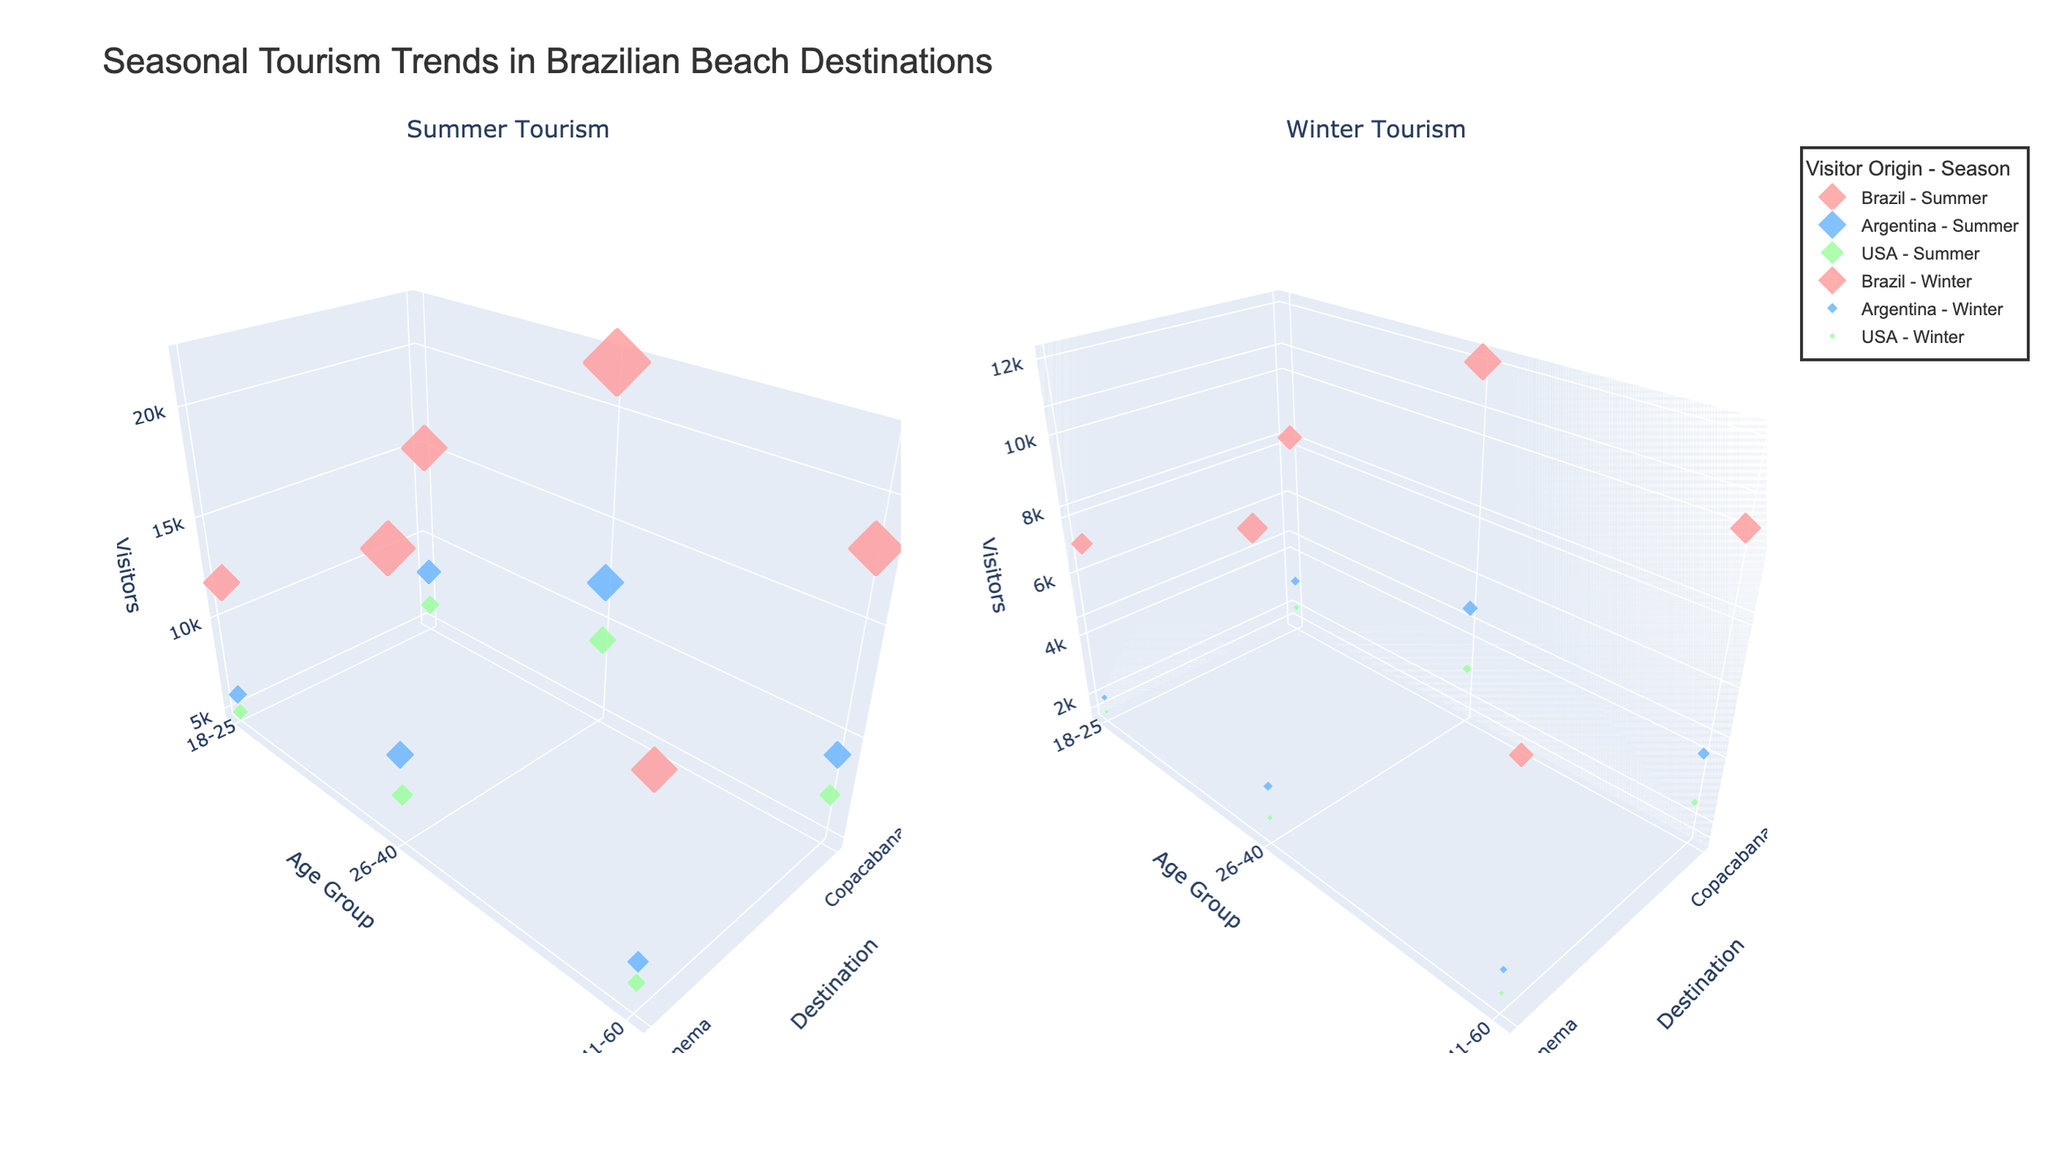What is the title of the figure? The title is located at the top of the plot and provides an overview of the subject being visualized. It reads "Seasonal Tourism Trends in Brazilian Beach Destinations".
Answer: Seasonal Tourism Trends in Brazilian Beach Destinations What season sees the highest number of visitors from Brazil for the 18-25 age group at Copacabana? By looking at the "Summer Tourism" subplot on the left, observe the marker size for Brazilians in the 18-25 age group at Copacabana. Compare it with the "Winter Tourism" subplot on the right. The marker size is larger in the summer.
Answer: Summer Which visitor origin group has fewer visitors in winter compared to summer at Ipanema for the 26-40 age group? Check the respective markers for each country of origin in both the "Summer Tourism" and "Winter Tourism" subplots at Ipanema for the 26-40 age group. The USA has fewer visitors in winter compared to summer at Ipanema.
Answer: USA What is the approximate size of the largest marker in the "Winter Tourism" subplot? The largest marker in the "Winter Tourism" subplot likely corresponds to Brazilian visitors at Copacabana for the 26-40 age group based on vertex height, and the markers are sized proportional to the number of visitors. The largest marker size appears to be around 44 (22000 / 500).
Answer: 44 How do visitor numbers change between summer and winter for Argentine visitors aged 41-60 at Ipanema? Compare the marker size for Argentine visitors in the 41-60 age group at Ipanema in both subplots. The marker size in summer is larger, suggesting higher visitor numbers in summer. The difference in the sizes indicates a decrease from summer to winter.
Answer: They decrease For the summer season, how does the number of visitors from Argentina to Copacabana compare to Ipanema for the 18-25 age group? In the "Summer Tourism" subplot, compare the marker sizes of Argentine visitors aged 18-25 at both Copacabana and Ipanema. Both markers show a similar size, but the Copacabana marker is slightly larger.
Answer: Copacabana has more Which age group has the highest number of visitors from the USA to Copacabana during the winter season? In the "Winter Tourism" subplot on the right side of the figure, look at the marker sizes for USA visitors at Copacabana. The largest marker corresponds to the 26-40 age group.
Answer: 26-40 How much do Brazilian visitors decrease from summer to winter at Copacabana for the 26-40 age group? Find the marker sizes for Brazilian visitors aged 26-40 at Copacabana in both subplots. The summer marker is noticeably larger. Subtract the winter visitor number (12000) from the summer visitor number (22000). The decrease is 22000 - 12000 = 10000.
Answer: 10000 When comparing all destinations and seasons, which visitor origin has the most consistent number of visitors? Look at all the markers across both subplots for each visitor origin and assess their size consistency across seasons and destinations. Brazilian visitors have relatively consistent marker sizes.
Answer: Brazil 